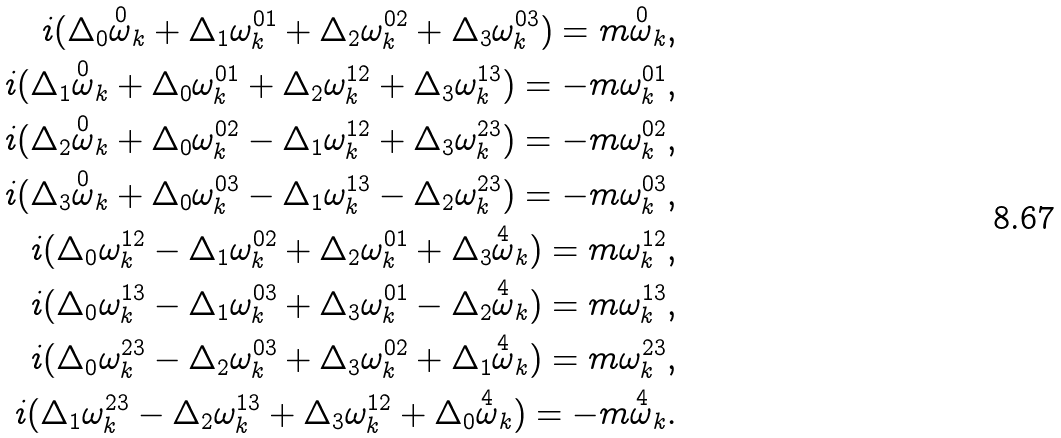<formula> <loc_0><loc_0><loc_500><loc_500>i ( \Delta _ { 0 } \overset { 0 } { \omega } _ { k } + \Delta _ { 1 } \omega _ { k } ^ { 0 1 } + \Delta _ { 2 } \omega _ { k } ^ { 0 2 } + \Delta _ { 3 } \omega _ { k } ^ { 0 3 } ) = m \overset { 0 } { \omega } _ { k } , \\ i ( \Delta _ { 1 } \overset { 0 } { \omega } _ { k } + \Delta _ { 0 } \omega _ { k } ^ { 0 1 } + \Delta _ { 2 } \omega _ { k } ^ { 1 2 } + \Delta _ { 3 } \omega _ { k } ^ { 1 3 } ) = - m \omega _ { k } ^ { 0 1 } , \\ i ( \Delta _ { 2 } \overset { 0 } { \omega } _ { k } + \Delta _ { 0 } \omega _ { k } ^ { 0 2 } - \Delta _ { 1 } \omega _ { k } ^ { 1 2 } + \Delta _ { 3 } \omega _ { k } ^ { 2 3 } ) = - m \omega _ { k } ^ { 0 2 } , \\ i ( \Delta _ { 3 } \overset { 0 } { \omega } _ { k } + \Delta _ { 0 } \omega _ { k } ^ { 0 3 } - \Delta _ { 1 } \omega _ { k } ^ { 1 3 } - \Delta _ { 2 } \omega _ { k } ^ { 2 3 } ) = - m \omega _ { k } ^ { 0 3 } , \\ i ( \Delta _ { 0 } \omega _ { k } ^ { 1 2 } - \Delta _ { 1 } \omega _ { k } ^ { 0 2 } + \Delta _ { 2 } \omega _ { k } ^ { 0 1 } + \Delta _ { 3 } \overset { 4 } { \omega } _ { k } ) = m \omega _ { k } ^ { 1 2 } , \\ i ( \Delta _ { 0 } \omega _ { k } ^ { 1 3 } - \Delta _ { 1 } \omega _ { k } ^ { 0 3 } + \Delta _ { 3 } \omega _ { k } ^ { 0 1 } - \Delta _ { 2 } \overset { 4 } { \omega } _ { k } ) = m \omega _ { k } ^ { 1 3 } , \\ i ( \Delta _ { 0 } \omega _ { k } ^ { 2 3 } - \Delta _ { 2 } \omega _ { k } ^ { 0 3 } + \Delta _ { 3 } \omega _ { k } ^ { 0 2 } + \Delta _ { 1 } \overset { 4 } { \omega } _ { k } ) = m \omega _ { k } ^ { 2 3 } , \\ i ( \Delta _ { 1 } \omega _ { k } ^ { 2 3 } - \Delta _ { 2 } \omega _ { k } ^ { 1 3 } + \Delta _ { 3 } \omega _ { k } ^ { 1 2 } + \Delta _ { 0 } \overset { 4 } { \omega } _ { k } ) = - m \overset { 4 } { \omega } _ { k } .</formula> 